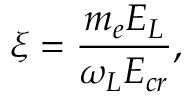Convert formula to latex. <formula><loc_0><loc_0><loc_500><loc_500>\xi = \frac { m _ { e } E _ { L } } { \omega _ { L } E _ { c r } } ,</formula> 